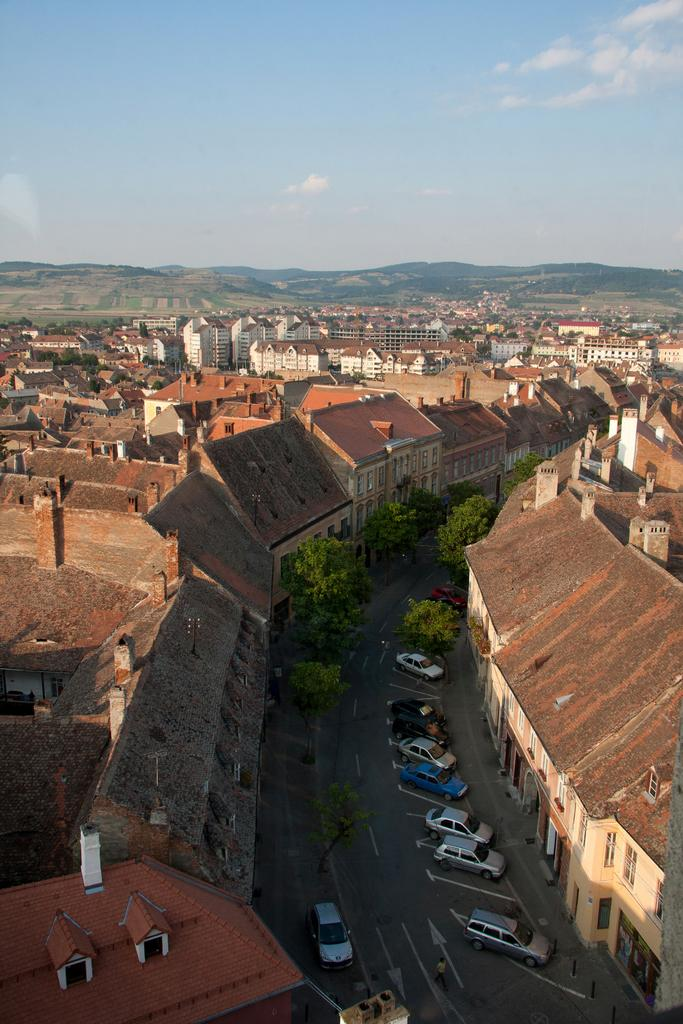What type of structures can be seen in the image? There are many buildings with windows in the image. What else is present in the image besides buildings? There is a road, many vehicles, trees, and hills visible in the background of the image. Can you see any clams on the playground in the image? There is no playground present in the image, and therefore no clams can be seen. 